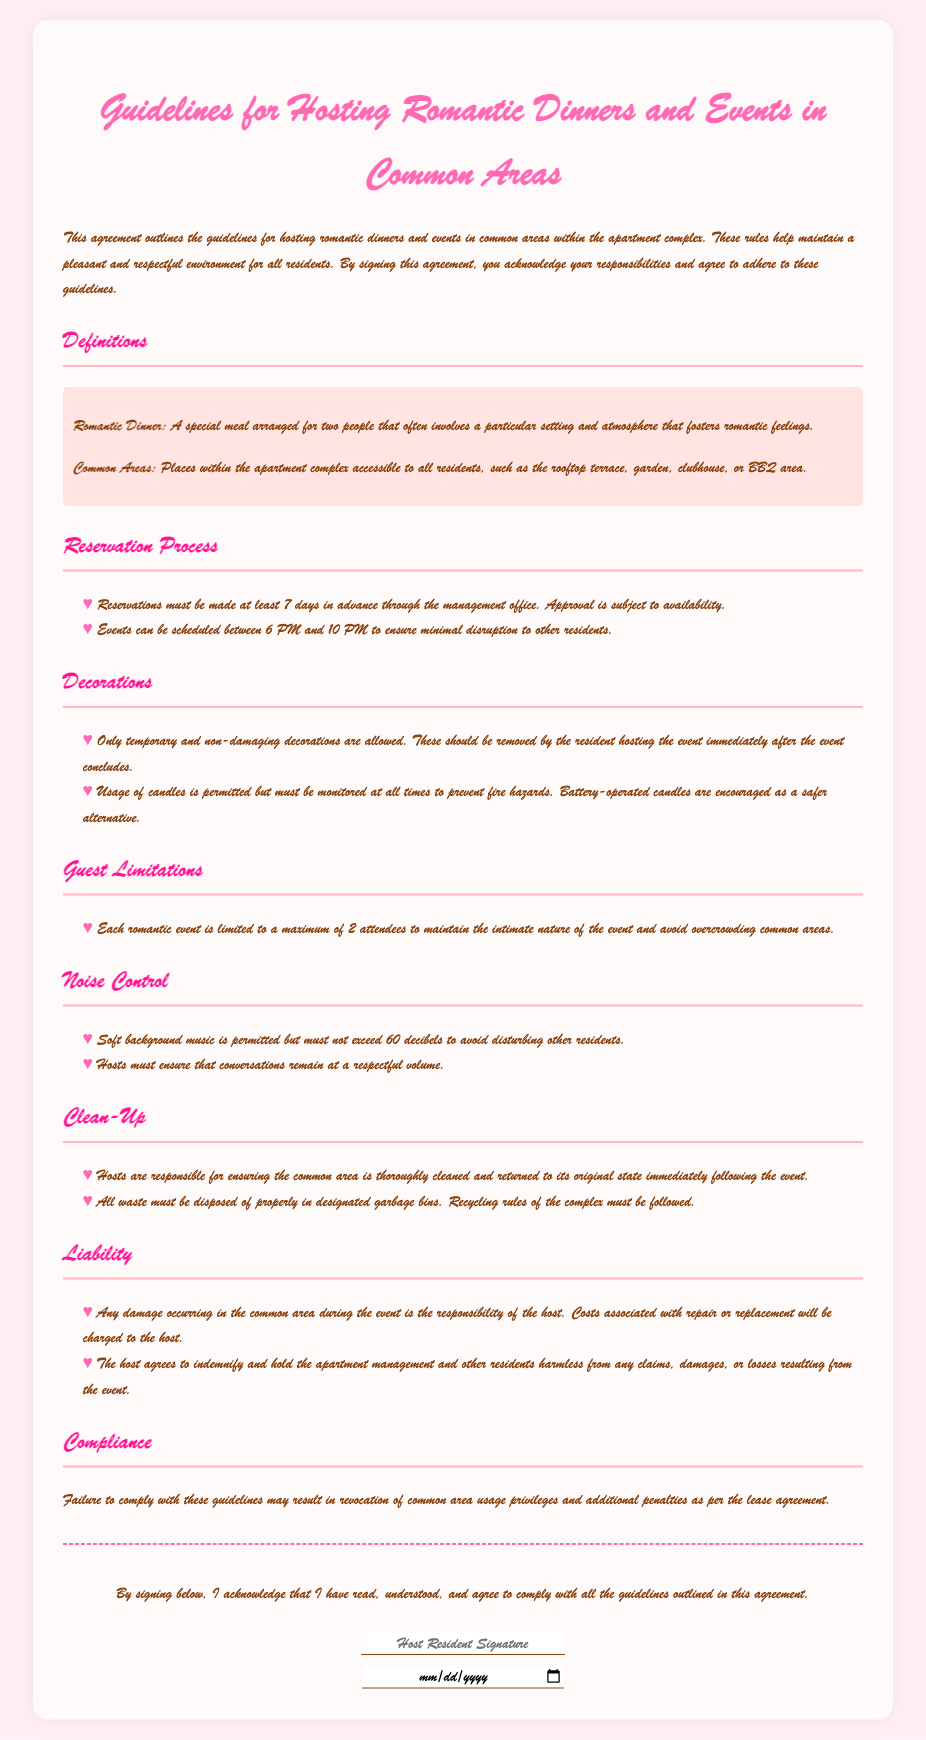What is the title of the document? The title of the document is presented at the top of the agreement.
Answer: Guidelines for Hosting Romantic Dinners and Events in Common Areas What is the maximum number of attendees allowed for each romantic event? The document specifies a guest limitation to maintain intimacy during events.
Answer: 2 What is the time frame during which events can be scheduled? The document indicates specific hours for hosting events to minimize disruption.
Answer: 6 PM to 10 PM How many days in advance must reservations be made? The reservation process section states the required advance notice for scheduling events.
Answer: 7 days What type of decorations are allowed? The guidelines specify what kind of decorations can be used during events in common areas.
Answer: Temporary and non-damaging What is the noise limit in decibels for background music? The noise control section sets a limitation on music volume to avoid disturbances.
Answer: 60 decibels Who is responsible for cleaning up after the event? The clean-up section outlines the responsibilities of the host following an event.
Answer: Hosts What are hosts required to do with waste? The clean-up guidelines detail proper waste disposal methods.
Answer: Dispose properly in designated garbage bins What will happen if someone fails to comply with the guidelines? The compliance section describes the consequences of not following the rules outlined in the document.
Answer: Revocation of common area usage privileges 